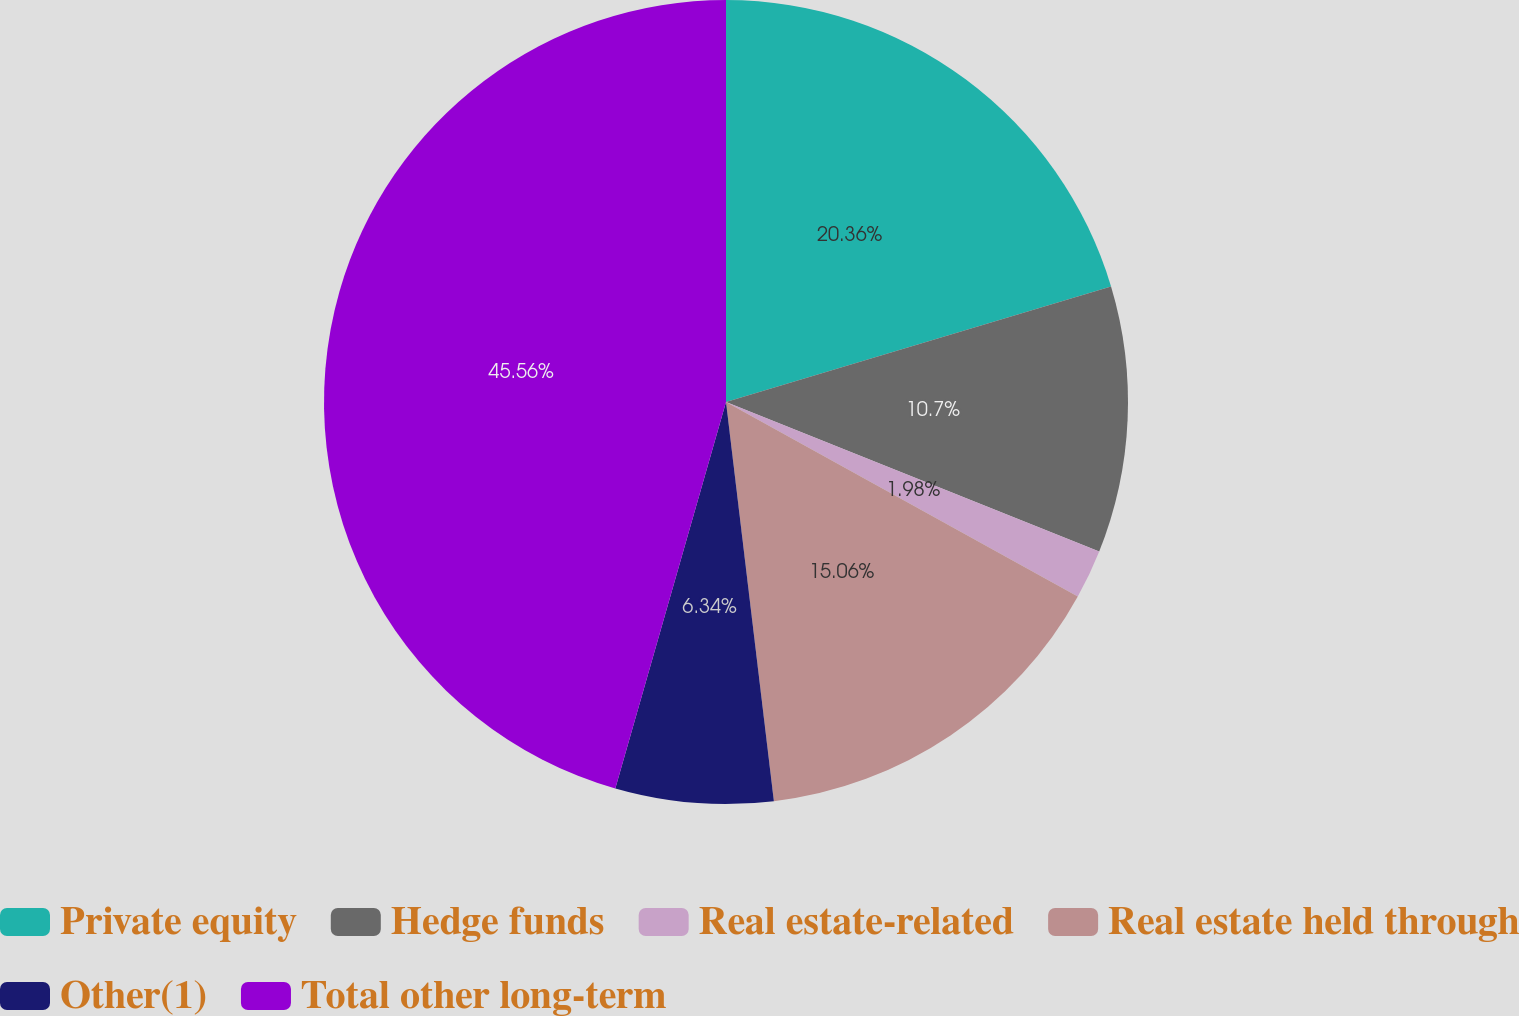<chart> <loc_0><loc_0><loc_500><loc_500><pie_chart><fcel>Private equity<fcel>Hedge funds<fcel>Real estate-related<fcel>Real estate held through<fcel>Other(1)<fcel>Total other long-term<nl><fcel>20.36%<fcel>10.7%<fcel>1.98%<fcel>15.06%<fcel>6.34%<fcel>45.56%<nl></chart> 